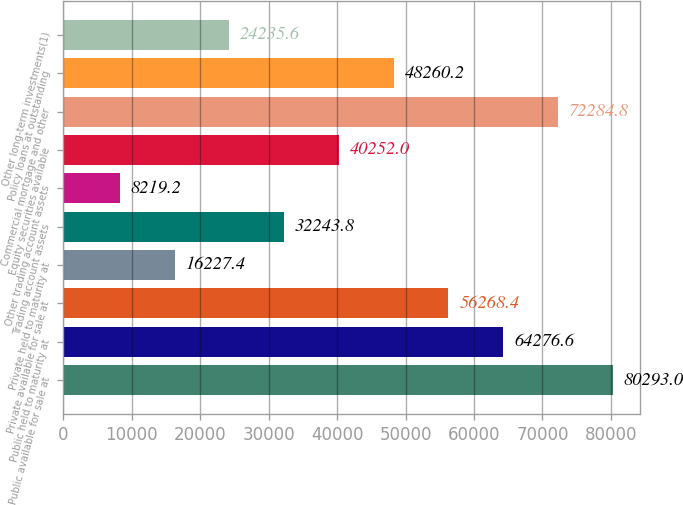<chart> <loc_0><loc_0><loc_500><loc_500><bar_chart><fcel>Public available for sale at<fcel>Public held to maturity at<fcel>Private available for sale at<fcel>Private held to maturity at<fcel>Trading account assets<fcel>Other trading account assets<fcel>Equity securities available<fcel>Commercial mortgage and other<fcel>Policy loans at outstanding<fcel>Other long-term investments(1)<nl><fcel>80293<fcel>64276.6<fcel>56268.4<fcel>16227.4<fcel>32243.8<fcel>8219.2<fcel>40252<fcel>72284.8<fcel>48260.2<fcel>24235.6<nl></chart> 